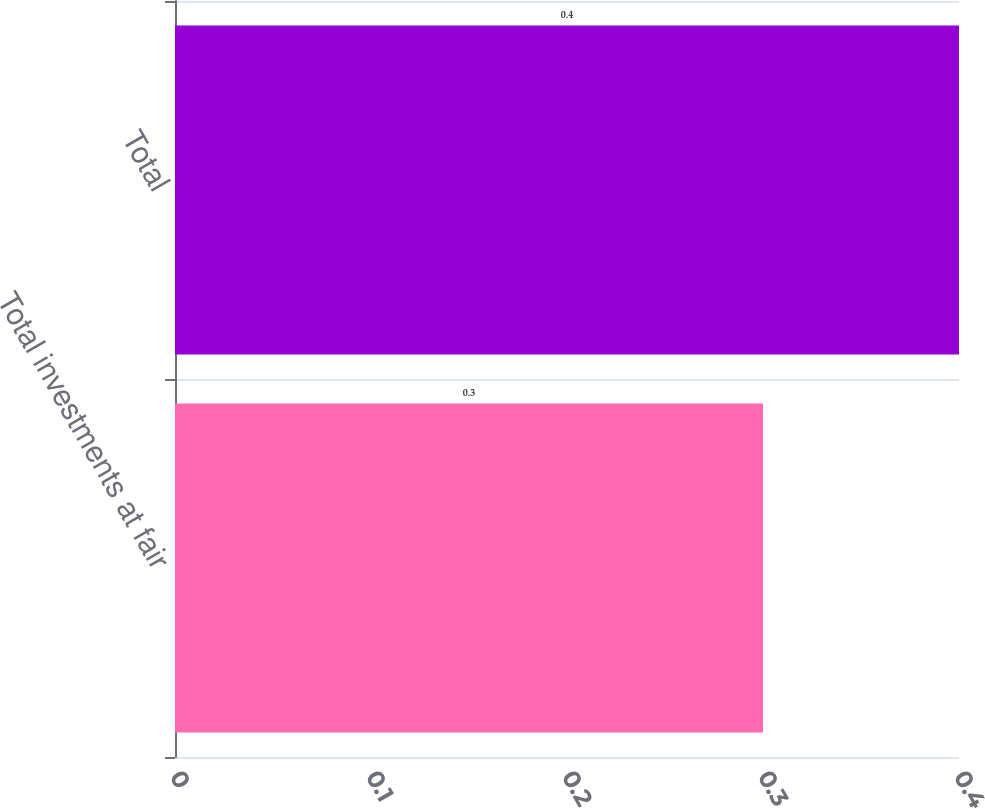Convert chart. <chart><loc_0><loc_0><loc_500><loc_500><bar_chart><fcel>Total investments at fair<fcel>Total<nl><fcel>0.3<fcel>0.4<nl></chart> 